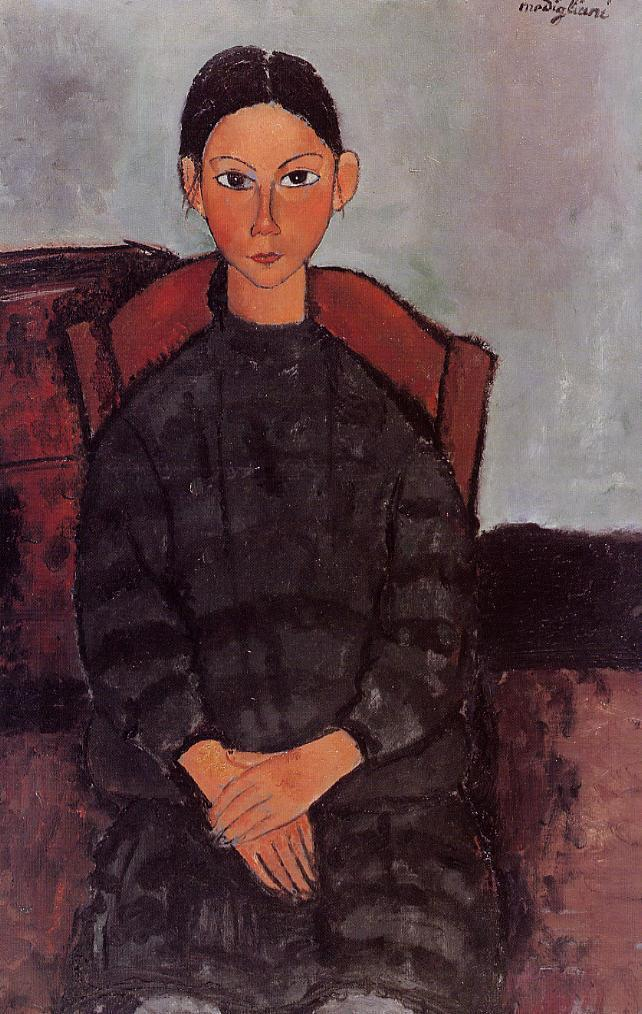Can you describe the main features of this image for me? The image depicts a seated woman exuding a reserved poise and direct gaze that command attention. Her clothing is simplistic yet sophisticated, characterized by a black dress exhibiting narrow pleats and a high neckline, reminiscent of the attire from the early 20th century. The chair's bold red contrasts with her dress and adds to the painting's depth. The subdued palette in the backdrop gives this portrait a contemplative ambiance. The painting exhibits characteristics of post-impressionist art, emphasized by the expressive lines and shapes used to convey the woman's features. The artwork does not overtly present a verified signature but is influenced by the styles of notable artists from the post-impressionist movement. 